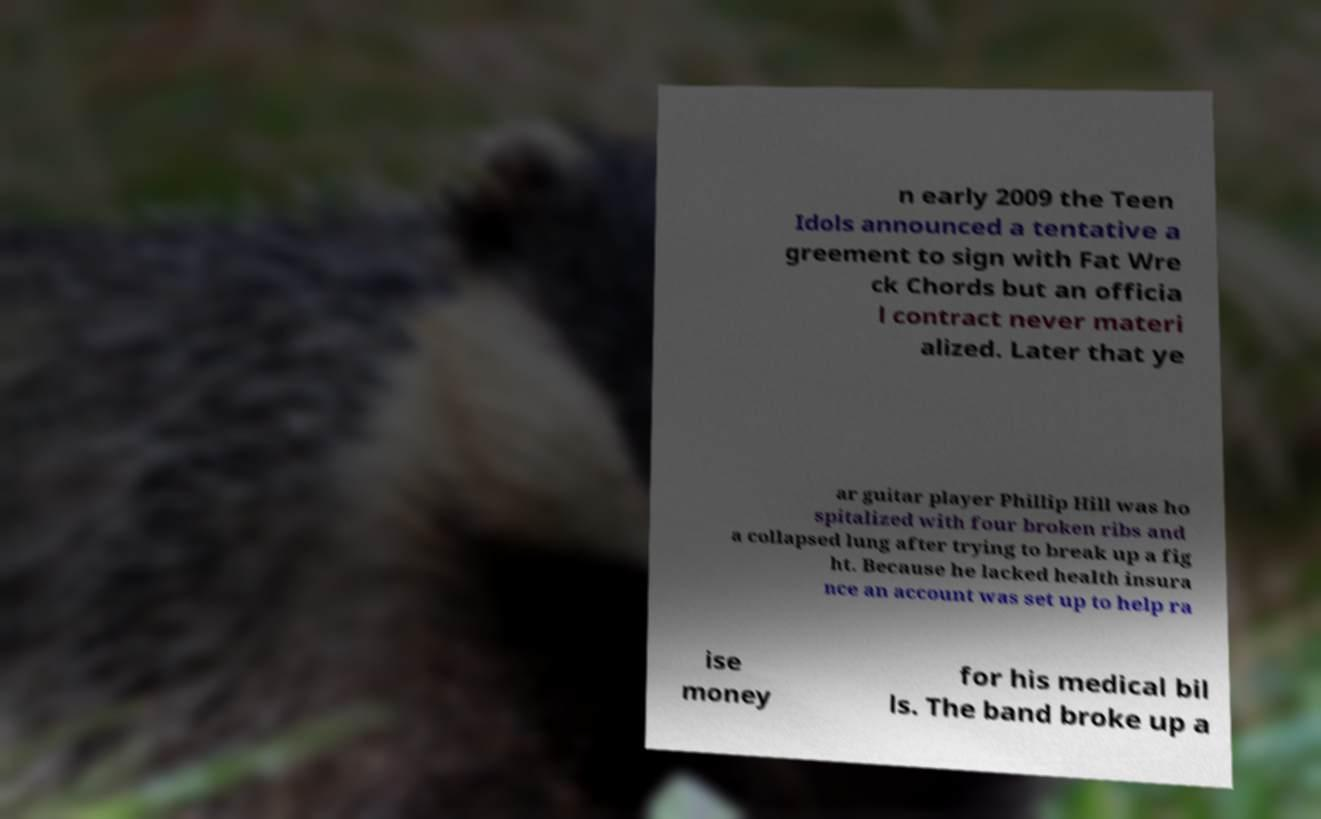Can you read and provide the text displayed in the image?This photo seems to have some interesting text. Can you extract and type it out for me? n early 2009 the Teen Idols announced a tentative a greement to sign with Fat Wre ck Chords but an officia l contract never materi alized. Later that ye ar guitar player Phillip Hill was ho spitalized with four broken ribs and a collapsed lung after trying to break up a fig ht. Because he lacked health insura nce an account was set up to help ra ise money for his medical bil ls. The band broke up a 